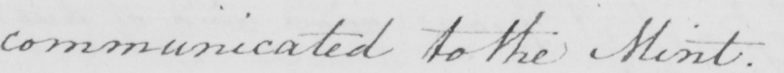What text is written in this handwritten line? communicated to the Mint . 